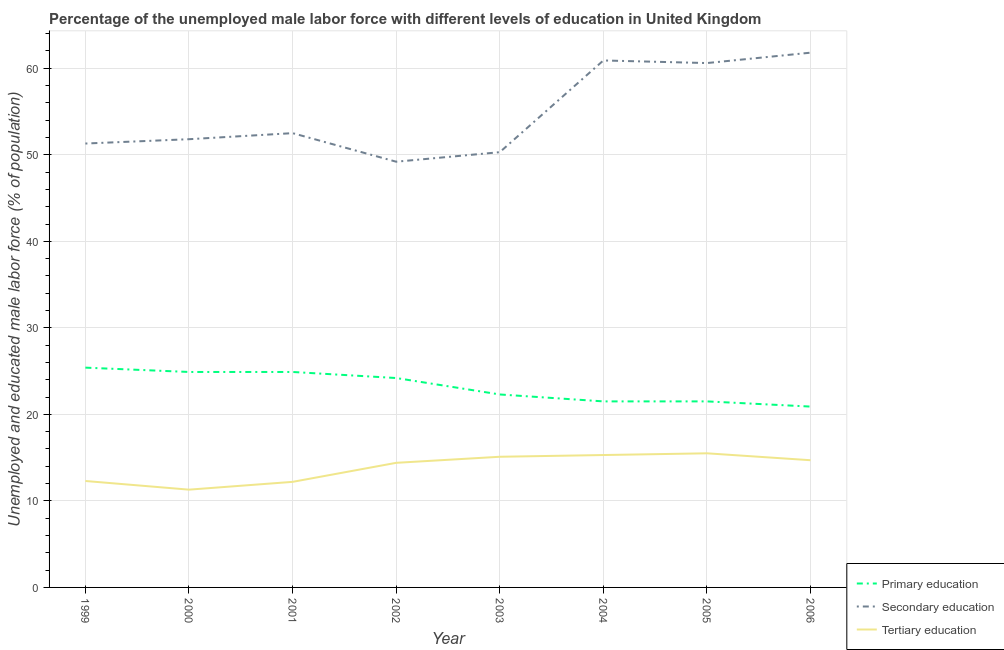Is the number of lines equal to the number of legend labels?
Your response must be concise. Yes. What is the percentage of male labor force who received primary education in 2002?
Your response must be concise. 24.2. Across all years, what is the minimum percentage of male labor force who received tertiary education?
Your response must be concise. 11.3. In which year was the percentage of male labor force who received primary education minimum?
Ensure brevity in your answer.  2006. What is the total percentage of male labor force who received primary education in the graph?
Your response must be concise. 185.6. What is the difference between the percentage of male labor force who received primary education in 2004 and that in 2006?
Offer a terse response. 0.6. What is the difference between the percentage of male labor force who received primary education in 2004 and the percentage of male labor force who received tertiary education in 2003?
Your answer should be compact. 6.4. What is the average percentage of male labor force who received secondary education per year?
Your answer should be compact. 54.8. In the year 2005, what is the difference between the percentage of male labor force who received primary education and percentage of male labor force who received tertiary education?
Provide a short and direct response. 6. In how many years, is the percentage of male labor force who received primary education greater than 24 %?
Your response must be concise. 4. What is the ratio of the percentage of male labor force who received secondary education in 2003 to that in 2005?
Offer a very short reply. 0.83. Is the percentage of male labor force who received secondary education in 1999 less than that in 2002?
Offer a very short reply. No. What is the difference between the highest and the second highest percentage of male labor force who received tertiary education?
Offer a terse response. 0.2. What is the difference between the highest and the lowest percentage of male labor force who received secondary education?
Your response must be concise. 12.6. Is the sum of the percentage of male labor force who received secondary education in 2003 and 2005 greater than the maximum percentage of male labor force who received tertiary education across all years?
Make the answer very short. Yes. How many lines are there?
Your answer should be compact. 3. How many years are there in the graph?
Make the answer very short. 8. What is the difference between two consecutive major ticks on the Y-axis?
Make the answer very short. 10. Are the values on the major ticks of Y-axis written in scientific E-notation?
Your response must be concise. No. Does the graph contain grids?
Your response must be concise. Yes. Where does the legend appear in the graph?
Provide a succinct answer. Bottom right. How are the legend labels stacked?
Give a very brief answer. Vertical. What is the title of the graph?
Provide a short and direct response. Percentage of the unemployed male labor force with different levels of education in United Kingdom. Does "Gaseous fuel" appear as one of the legend labels in the graph?
Make the answer very short. No. What is the label or title of the Y-axis?
Keep it short and to the point. Unemployed and educated male labor force (% of population). What is the Unemployed and educated male labor force (% of population) of Primary education in 1999?
Make the answer very short. 25.4. What is the Unemployed and educated male labor force (% of population) of Secondary education in 1999?
Offer a very short reply. 51.3. What is the Unemployed and educated male labor force (% of population) of Tertiary education in 1999?
Offer a terse response. 12.3. What is the Unemployed and educated male labor force (% of population) of Primary education in 2000?
Offer a terse response. 24.9. What is the Unemployed and educated male labor force (% of population) of Secondary education in 2000?
Give a very brief answer. 51.8. What is the Unemployed and educated male labor force (% of population) of Tertiary education in 2000?
Provide a succinct answer. 11.3. What is the Unemployed and educated male labor force (% of population) of Primary education in 2001?
Your response must be concise. 24.9. What is the Unemployed and educated male labor force (% of population) in Secondary education in 2001?
Provide a succinct answer. 52.5. What is the Unemployed and educated male labor force (% of population) of Tertiary education in 2001?
Your response must be concise. 12.2. What is the Unemployed and educated male labor force (% of population) of Primary education in 2002?
Make the answer very short. 24.2. What is the Unemployed and educated male labor force (% of population) of Secondary education in 2002?
Give a very brief answer. 49.2. What is the Unemployed and educated male labor force (% of population) of Tertiary education in 2002?
Keep it short and to the point. 14.4. What is the Unemployed and educated male labor force (% of population) of Primary education in 2003?
Your answer should be very brief. 22.3. What is the Unemployed and educated male labor force (% of population) of Secondary education in 2003?
Ensure brevity in your answer.  50.3. What is the Unemployed and educated male labor force (% of population) in Tertiary education in 2003?
Make the answer very short. 15.1. What is the Unemployed and educated male labor force (% of population) of Primary education in 2004?
Your answer should be very brief. 21.5. What is the Unemployed and educated male labor force (% of population) of Secondary education in 2004?
Provide a succinct answer. 60.9. What is the Unemployed and educated male labor force (% of population) in Tertiary education in 2004?
Offer a very short reply. 15.3. What is the Unemployed and educated male labor force (% of population) of Primary education in 2005?
Keep it short and to the point. 21.5. What is the Unemployed and educated male labor force (% of population) of Secondary education in 2005?
Provide a succinct answer. 60.6. What is the Unemployed and educated male labor force (% of population) of Tertiary education in 2005?
Your response must be concise. 15.5. What is the Unemployed and educated male labor force (% of population) of Primary education in 2006?
Make the answer very short. 20.9. What is the Unemployed and educated male labor force (% of population) of Secondary education in 2006?
Ensure brevity in your answer.  61.8. What is the Unemployed and educated male labor force (% of population) in Tertiary education in 2006?
Make the answer very short. 14.7. Across all years, what is the maximum Unemployed and educated male labor force (% of population) of Primary education?
Provide a short and direct response. 25.4. Across all years, what is the maximum Unemployed and educated male labor force (% of population) of Secondary education?
Your answer should be very brief. 61.8. Across all years, what is the maximum Unemployed and educated male labor force (% of population) of Tertiary education?
Your answer should be very brief. 15.5. Across all years, what is the minimum Unemployed and educated male labor force (% of population) in Primary education?
Ensure brevity in your answer.  20.9. Across all years, what is the minimum Unemployed and educated male labor force (% of population) of Secondary education?
Offer a very short reply. 49.2. Across all years, what is the minimum Unemployed and educated male labor force (% of population) in Tertiary education?
Your answer should be compact. 11.3. What is the total Unemployed and educated male labor force (% of population) of Primary education in the graph?
Ensure brevity in your answer.  185.6. What is the total Unemployed and educated male labor force (% of population) of Secondary education in the graph?
Offer a terse response. 438.4. What is the total Unemployed and educated male labor force (% of population) in Tertiary education in the graph?
Keep it short and to the point. 110.8. What is the difference between the Unemployed and educated male labor force (% of population) of Tertiary education in 1999 and that in 2000?
Provide a succinct answer. 1. What is the difference between the Unemployed and educated male labor force (% of population) in Primary education in 1999 and that in 2002?
Keep it short and to the point. 1.2. What is the difference between the Unemployed and educated male labor force (% of population) in Secondary education in 1999 and that in 2002?
Provide a short and direct response. 2.1. What is the difference between the Unemployed and educated male labor force (% of population) of Primary education in 1999 and that in 2003?
Ensure brevity in your answer.  3.1. What is the difference between the Unemployed and educated male labor force (% of population) of Tertiary education in 1999 and that in 2003?
Give a very brief answer. -2.8. What is the difference between the Unemployed and educated male labor force (% of population) in Secondary education in 1999 and that in 2004?
Make the answer very short. -9.6. What is the difference between the Unemployed and educated male labor force (% of population) of Tertiary education in 1999 and that in 2004?
Keep it short and to the point. -3. What is the difference between the Unemployed and educated male labor force (% of population) in Secondary education in 1999 and that in 2005?
Give a very brief answer. -9.3. What is the difference between the Unemployed and educated male labor force (% of population) in Secondary education in 1999 and that in 2006?
Your answer should be very brief. -10.5. What is the difference between the Unemployed and educated male labor force (% of population) of Tertiary education in 2000 and that in 2001?
Provide a short and direct response. -0.9. What is the difference between the Unemployed and educated male labor force (% of population) in Secondary education in 2000 and that in 2002?
Keep it short and to the point. 2.6. What is the difference between the Unemployed and educated male labor force (% of population) of Tertiary education in 2000 and that in 2002?
Your response must be concise. -3.1. What is the difference between the Unemployed and educated male labor force (% of population) in Primary education in 2000 and that in 2003?
Your response must be concise. 2.6. What is the difference between the Unemployed and educated male labor force (% of population) of Tertiary education in 2000 and that in 2004?
Keep it short and to the point. -4. What is the difference between the Unemployed and educated male labor force (% of population) of Primary education in 2000 and that in 2005?
Your answer should be very brief. 3.4. What is the difference between the Unemployed and educated male labor force (% of population) of Tertiary education in 2000 and that in 2005?
Make the answer very short. -4.2. What is the difference between the Unemployed and educated male labor force (% of population) in Primary education in 2000 and that in 2006?
Offer a terse response. 4. What is the difference between the Unemployed and educated male labor force (% of population) of Primary education in 2001 and that in 2002?
Give a very brief answer. 0.7. What is the difference between the Unemployed and educated male labor force (% of population) of Secondary education in 2001 and that in 2002?
Offer a very short reply. 3.3. What is the difference between the Unemployed and educated male labor force (% of population) of Secondary education in 2001 and that in 2003?
Your response must be concise. 2.2. What is the difference between the Unemployed and educated male labor force (% of population) in Tertiary education in 2001 and that in 2003?
Your answer should be compact. -2.9. What is the difference between the Unemployed and educated male labor force (% of population) in Primary education in 2001 and that in 2004?
Ensure brevity in your answer.  3.4. What is the difference between the Unemployed and educated male labor force (% of population) in Tertiary education in 2001 and that in 2004?
Offer a terse response. -3.1. What is the difference between the Unemployed and educated male labor force (% of population) in Secondary education in 2002 and that in 2003?
Offer a very short reply. -1.1. What is the difference between the Unemployed and educated male labor force (% of population) in Tertiary education in 2002 and that in 2003?
Keep it short and to the point. -0.7. What is the difference between the Unemployed and educated male labor force (% of population) in Primary education in 2002 and that in 2004?
Give a very brief answer. 2.7. What is the difference between the Unemployed and educated male labor force (% of population) of Tertiary education in 2002 and that in 2005?
Offer a very short reply. -1.1. What is the difference between the Unemployed and educated male labor force (% of population) in Secondary education in 2002 and that in 2006?
Ensure brevity in your answer.  -12.6. What is the difference between the Unemployed and educated male labor force (% of population) in Tertiary education in 2003 and that in 2004?
Provide a short and direct response. -0.2. What is the difference between the Unemployed and educated male labor force (% of population) in Secondary education in 2003 and that in 2005?
Keep it short and to the point. -10.3. What is the difference between the Unemployed and educated male labor force (% of population) in Tertiary education in 2003 and that in 2005?
Offer a terse response. -0.4. What is the difference between the Unemployed and educated male labor force (% of population) in Primary education in 2004 and that in 2005?
Your answer should be very brief. 0. What is the difference between the Unemployed and educated male labor force (% of population) in Secondary education in 2004 and that in 2006?
Offer a terse response. -0.9. What is the difference between the Unemployed and educated male labor force (% of population) in Primary education in 2005 and that in 2006?
Give a very brief answer. 0.6. What is the difference between the Unemployed and educated male labor force (% of population) in Tertiary education in 2005 and that in 2006?
Offer a very short reply. 0.8. What is the difference between the Unemployed and educated male labor force (% of population) in Primary education in 1999 and the Unemployed and educated male labor force (% of population) in Secondary education in 2000?
Offer a terse response. -26.4. What is the difference between the Unemployed and educated male labor force (% of population) in Primary education in 1999 and the Unemployed and educated male labor force (% of population) in Tertiary education in 2000?
Your response must be concise. 14.1. What is the difference between the Unemployed and educated male labor force (% of population) of Primary education in 1999 and the Unemployed and educated male labor force (% of population) of Secondary education in 2001?
Provide a succinct answer. -27.1. What is the difference between the Unemployed and educated male labor force (% of population) in Primary education in 1999 and the Unemployed and educated male labor force (% of population) in Tertiary education in 2001?
Ensure brevity in your answer.  13.2. What is the difference between the Unemployed and educated male labor force (% of population) in Secondary education in 1999 and the Unemployed and educated male labor force (% of population) in Tertiary education in 2001?
Offer a terse response. 39.1. What is the difference between the Unemployed and educated male labor force (% of population) of Primary education in 1999 and the Unemployed and educated male labor force (% of population) of Secondary education in 2002?
Your answer should be compact. -23.8. What is the difference between the Unemployed and educated male labor force (% of population) of Primary education in 1999 and the Unemployed and educated male labor force (% of population) of Tertiary education in 2002?
Your answer should be compact. 11. What is the difference between the Unemployed and educated male labor force (% of population) in Secondary education in 1999 and the Unemployed and educated male labor force (% of population) in Tertiary education in 2002?
Make the answer very short. 36.9. What is the difference between the Unemployed and educated male labor force (% of population) of Primary education in 1999 and the Unemployed and educated male labor force (% of population) of Secondary education in 2003?
Make the answer very short. -24.9. What is the difference between the Unemployed and educated male labor force (% of population) of Secondary education in 1999 and the Unemployed and educated male labor force (% of population) of Tertiary education in 2003?
Ensure brevity in your answer.  36.2. What is the difference between the Unemployed and educated male labor force (% of population) in Primary education in 1999 and the Unemployed and educated male labor force (% of population) in Secondary education in 2004?
Your answer should be compact. -35.5. What is the difference between the Unemployed and educated male labor force (% of population) in Primary education in 1999 and the Unemployed and educated male labor force (% of population) in Tertiary education in 2004?
Make the answer very short. 10.1. What is the difference between the Unemployed and educated male labor force (% of population) in Primary education in 1999 and the Unemployed and educated male labor force (% of population) in Secondary education in 2005?
Keep it short and to the point. -35.2. What is the difference between the Unemployed and educated male labor force (% of population) of Primary education in 1999 and the Unemployed and educated male labor force (% of population) of Tertiary education in 2005?
Make the answer very short. 9.9. What is the difference between the Unemployed and educated male labor force (% of population) of Secondary education in 1999 and the Unemployed and educated male labor force (% of population) of Tertiary education in 2005?
Ensure brevity in your answer.  35.8. What is the difference between the Unemployed and educated male labor force (% of population) of Primary education in 1999 and the Unemployed and educated male labor force (% of population) of Secondary education in 2006?
Ensure brevity in your answer.  -36.4. What is the difference between the Unemployed and educated male labor force (% of population) in Secondary education in 1999 and the Unemployed and educated male labor force (% of population) in Tertiary education in 2006?
Provide a succinct answer. 36.6. What is the difference between the Unemployed and educated male labor force (% of population) of Primary education in 2000 and the Unemployed and educated male labor force (% of population) of Secondary education in 2001?
Your answer should be compact. -27.6. What is the difference between the Unemployed and educated male labor force (% of population) of Primary education in 2000 and the Unemployed and educated male labor force (% of population) of Tertiary education in 2001?
Give a very brief answer. 12.7. What is the difference between the Unemployed and educated male labor force (% of population) of Secondary education in 2000 and the Unemployed and educated male labor force (% of population) of Tertiary education in 2001?
Make the answer very short. 39.6. What is the difference between the Unemployed and educated male labor force (% of population) of Primary education in 2000 and the Unemployed and educated male labor force (% of population) of Secondary education in 2002?
Your answer should be compact. -24.3. What is the difference between the Unemployed and educated male labor force (% of population) of Secondary education in 2000 and the Unemployed and educated male labor force (% of population) of Tertiary education in 2002?
Your answer should be compact. 37.4. What is the difference between the Unemployed and educated male labor force (% of population) in Primary education in 2000 and the Unemployed and educated male labor force (% of population) in Secondary education in 2003?
Your response must be concise. -25.4. What is the difference between the Unemployed and educated male labor force (% of population) of Secondary education in 2000 and the Unemployed and educated male labor force (% of population) of Tertiary education in 2003?
Provide a succinct answer. 36.7. What is the difference between the Unemployed and educated male labor force (% of population) of Primary education in 2000 and the Unemployed and educated male labor force (% of population) of Secondary education in 2004?
Your answer should be compact. -36. What is the difference between the Unemployed and educated male labor force (% of population) of Secondary education in 2000 and the Unemployed and educated male labor force (% of population) of Tertiary education in 2004?
Give a very brief answer. 36.5. What is the difference between the Unemployed and educated male labor force (% of population) of Primary education in 2000 and the Unemployed and educated male labor force (% of population) of Secondary education in 2005?
Your answer should be compact. -35.7. What is the difference between the Unemployed and educated male labor force (% of population) of Primary education in 2000 and the Unemployed and educated male labor force (% of population) of Tertiary education in 2005?
Offer a very short reply. 9.4. What is the difference between the Unemployed and educated male labor force (% of population) of Secondary education in 2000 and the Unemployed and educated male labor force (% of population) of Tertiary education in 2005?
Your response must be concise. 36.3. What is the difference between the Unemployed and educated male labor force (% of population) in Primary education in 2000 and the Unemployed and educated male labor force (% of population) in Secondary education in 2006?
Make the answer very short. -36.9. What is the difference between the Unemployed and educated male labor force (% of population) in Secondary education in 2000 and the Unemployed and educated male labor force (% of population) in Tertiary education in 2006?
Offer a very short reply. 37.1. What is the difference between the Unemployed and educated male labor force (% of population) in Primary education in 2001 and the Unemployed and educated male labor force (% of population) in Secondary education in 2002?
Make the answer very short. -24.3. What is the difference between the Unemployed and educated male labor force (% of population) in Primary education in 2001 and the Unemployed and educated male labor force (% of population) in Tertiary education in 2002?
Offer a terse response. 10.5. What is the difference between the Unemployed and educated male labor force (% of population) of Secondary education in 2001 and the Unemployed and educated male labor force (% of population) of Tertiary education in 2002?
Your answer should be compact. 38.1. What is the difference between the Unemployed and educated male labor force (% of population) of Primary education in 2001 and the Unemployed and educated male labor force (% of population) of Secondary education in 2003?
Your answer should be compact. -25.4. What is the difference between the Unemployed and educated male labor force (% of population) in Primary education in 2001 and the Unemployed and educated male labor force (% of population) in Tertiary education in 2003?
Make the answer very short. 9.8. What is the difference between the Unemployed and educated male labor force (% of population) of Secondary education in 2001 and the Unemployed and educated male labor force (% of population) of Tertiary education in 2003?
Provide a succinct answer. 37.4. What is the difference between the Unemployed and educated male labor force (% of population) of Primary education in 2001 and the Unemployed and educated male labor force (% of population) of Secondary education in 2004?
Your answer should be compact. -36. What is the difference between the Unemployed and educated male labor force (% of population) of Secondary education in 2001 and the Unemployed and educated male labor force (% of population) of Tertiary education in 2004?
Offer a terse response. 37.2. What is the difference between the Unemployed and educated male labor force (% of population) in Primary education in 2001 and the Unemployed and educated male labor force (% of population) in Secondary education in 2005?
Make the answer very short. -35.7. What is the difference between the Unemployed and educated male labor force (% of population) in Primary education in 2001 and the Unemployed and educated male labor force (% of population) in Tertiary education in 2005?
Offer a very short reply. 9.4. What is the difference between the Unemployed and educated male labor force (% of population) of Secondary education in 2001 and the Unemployed and educated male labor force (% of population) of Tertiary education in 2005?
Keep it short and to the point. 37. What is the difference between the Unemployed and educated male labor force (% of population) of Primary education in 2001 and the Unemployed and educated male labor force (% of population) of Secondary education in 2006?
Provide a short and direct response. -36.9. What is the difference between the Unemployed and educated male labor force (% of population) in Secondary education in 2001 and the Unemployed and educated male labor force (% of population) in Tertiary education in 2006?
Offer a terse response. 37.8. What is the difference between the Unemployed and educated male labor force (% of population) of Primary education in 2002 and the Unemployed and educated male labor force (% of population) of Secondary education in 2003?
Offer a terse response. -26.1. What is the difference between the Unemployed and educated male labor force (% of population) of Secondary education in 2002 and the Unemployed and educated male labor force (% of population) of Tertiary education in 2003?
Your response must be concise. 34.1. What is the difference between the Unemployed and educated male labor force (% of population) of Primary education in 2002 and the Unemployed and educated male labor force (% of population) of Secondary education in 2004?
Your response must be concise. -36.7. What is the difference between the Unemployed and educated male labor force (% of population) of Secondary education in 2002 and the Unemployed and educated male labor force (% of population) of Tertiary education in 2004?
Offer a terse response. 33.9. What is the difference between the Unemployed and educated male labor force (% of population) of Primary education in 2002 and the Unemployed and educated male labor force (% of population) of Secondary education in 2005?
Your response must be concise. -36.4. What is the difference between the Unemployed and educated male labor force (% of population) in Secondary education in 2002 and the Unemployed and educated male labor force (% of population) in Tertiary education in 2005?
Offer a very short reply. 33.7. What is the difference between the Unemployed and educated male labor force (% of population) of Primary education in 2002 and the Unemployed and educated male labor force (% of population) of Secondary education in 2006?
Offer a very short reply. -37.6. What is the difference between the Unemployed and educated male labor force (% of population) of Primary education in 2002 and the Unemployed and educated male labor force (% of population) of Tertiary education in 2006?
Your answer should be very brief. 9.5. What is the difference between the Unemployed and educated male labor force (% of population) of Secondary education in 2002 and the Unemployed and educated male labor force (% of population) of Tertiary education in 2006?
Give a very brief answer. 34.5. What is the difference between the Unemployed and educated male labor force (% of population) of Primary education in 2003 and the Unemployed and educated male labor force (% of population) of Secondary education in 2004?
Give a very brief answer. -38.6. What is the difference between the Unemployed and educated male labor force (% of population) in Primary education in 2003 and the Unemployed and educated male labor force (% of population) in Tertiary education in 2004?
Ensure brevity in your answer.  7. What is the difference between the Unemployed and educated male labor force (% of population) in Secondary education in 2003 and the Unemployed and educated male labor force (% of population) in Tertiary education in 2004?
Keep it short and to the point. 35. What is the difference between the Unemployed and educated male labor force (% of population) of Primary education in 2003 and the Unemployed and educated male labor force (% of population) of Secondary education in 2005?
Your response must be concise. -38.3. What is the difference between the Unemployed and educated male labor force (% of population) of Secondary education in 2003 and the Unemployed and educated male labor force (% of population) of Tertiary education in 2005?
Provide a succinct answer. 34.8. What is the difference between the Unemployed and educated male labor force (% of population) in Primary education in 2003 and the Unemployed and educated male labor force (% of population) in Secondary education in 2006?
Your response must be concise. -39.5. What is the difference between the Unemployed and educated male labor force (% of population) in Primary education in 2003 and the Unemployed and educated male labor force (% of population) in Tertiary education in 2006?
Ensure brevity in your answer.  7.6. What is the difference between the Unemployed and educated male labor force (% of population) in Secondary education in 2003 and the Unemployed and educated male labor force (% of population) in Tertiary education in 2006?
Provide a succinct answer. 35.6. What is the difference between the Unemployed and educated male labor force (% of population) of Primary education in 2004 and the Unemployed and educated male labor force (% of population) of Secondary education in 2005?
Your answer should be very brief. -39.1. What is the difference between the Unemployed and educated male labor force (% of population) of Secondary education in 2004 and the Unemployed and educated male labor force (% of population) of Tertiary education in 2005?
Your answer should be very brief. 45.4. What is the difference between the Unemployed and educated male labor force (% of population) of Primary education in 2004 and the Unemployed and educated male labor force (% of population) of Secondary education in 2006?
Make the answer very short. -40.3. What is the difference between the Unemployed and educated male labor force (% of population) in Primary education in 2004 and the Unemployed and educated male labor force (% of population) in Tertiary education in 2006?
Make the answer very short. 6.8. What is the difference between the Unemployed and educated male labor force (% of population) of Secondary education in 2004 and the Unemployed and educated male labor force (% of population) of Tertiary education in 2006?
Your response must be concise. 46.2. What is the difference between the Unemployed and educated male labor force (% of population) of Primary education in 2005 and the Unemployed and educated male labor force (% of population) of Secondary education in 2006?
Offer a very short reply. -40.3. What is the difference between the Unemployed and educated male labor force (% of population) in Primary education in 2005 and the Unemployed and educated male labor force (% of population) in Tertiary education in 2006?
Provide a succinct answer. 6.8. What is the difference between the Unemployed and educated male labor force (% of population) of Secondary education in 2005 and the Unemployed and educated male labor force (% of population) of Tertiary education in 2006?
Give a very brief answer. 45.9. What is the average Unemployed and educated male labor force (% of population) of Primary education per year?
Your response must be concise. 23.2. What is the average Unemployed and educated male labor force (% of population) of Secondary education per year?
Offer a terse response. 54.8. What is the average Unemployed and educated male labor force (% of population) of Tertiary education per year?
Provide a short and direct response. 13.85. In the year 1999, what is the difference between the Unemployed and educated male labor force (% of population) of Primary education and Unemployed and educated male labor force (% of population) of Secondary education?
Provide a succinct answer. -25.9. In the year 2000, what is the difference between the Unemployed and educated male labor force (% of population) in Primary education and Unemployed and educated male labor force (% of population) in Secondary education?
Your answer should be compact. -26.9. In the year 2000, what is the difference between the Unemployed and educated male labor force (% of population) of Secondary education and Unemployed and educated male labor force (% of population) of Tertiary education?
Provide a short and direct response. 40.5. In the year 2001, what is the difference between the Unemployed and educated male labor force (% of population) in Primary education and Unemployed and educated male labor force (% of population) in Secondary education?
Make the answer very short. -27.6. In the year 2001, what is the difference between the Unemployed and educated male labor force (% of population) of Secondary education and Unemployed and educated male labor force (% of population) of Tertiary education?
Provide a succinct answer. 40.3. In the year 2002, what is the difference between the Unemployed and educated male labor force (% of population) of Primary education and Unemployed and educated male labor force (% of population) of Secondary education?
Keep it short and to the point. -25. In the year 2002, what is the difference between the Unemployed and educated male labor force (% of population) in Secondary education and Unemployed and educated male labor force (% of population) in Tertiary education?
Keep it short and to the point. 34.8. In the year 2003, what is the difference between the Unemployed and educated male labor force (% of population) in Secondary education and Unemployed and educated male labor force (% of population) in Tertiary education?
Give a very brief answer. 35.2. In the year 2004, what is the difference between the Unemployed and educated male labor force (% of population) in Primary education and Unemployed and educated male labor force (% of population) in Secondary education?
Offer a terse response. -39.4. In the year 2004, what is the difference between the Unemployed and educated male labor force (% of population) of Secondary education and Unemployed and educated male labor force (% of population) of Tertiary education?
Provide a succinct answer. 45.6. In the year 2005, what is the difference between the Unemployed and educated male labor force (% of population) of Primary education and Unemployed and educated male labor force (% of population) of Secondary education?
Provide a succinct answer. -39.1. In the year 2005, what is the difference between the Unemployed and educated male labor force (% of population) of Primary education and Unemployed and educated male labor force (% of population) of Tertiary education?
Ensure brevity in your answer.  6. In the year 2005, what is the difference between the Unemployed and educated male labor force (% of population) of Secondary education and Unemployed and educated male labor force (% of population) of Tertiary education?
Offer a terse response. 45.1. In the year 2006, what is the difference between the Unemployed and educated male labor force (% of population) in Primary education and Unemployed and educated male labor force (% of population) in Secondary education?
Offer a terse response. -40.9. In the year 2006, what is the difference between the Unemployed and educated male labor force (% of population) of Primary education and Unemployed and educated male labor force (% of population) of Tertiary education?
Offer a very short reply. 6.2. In the year 2006, what is the difference between the Unemployed and educated male labor force (% of population) in Secondary education and Unemployed and educated male labor force (% of population) in Tertiary education?
Ensure brevity in your answer.  47.1. What is the ratio of the Unemployed and educated male labor force (% of population) of Primary education in 1999 to that in 2000?
Provide a succinct answer. 1.02. What is the ratio of the Unemployed and educated male labor force (% of population) in Secondary education in 1999 to that in 2000?
Your response must be concise. 0.99. What is the ratio of the Unemployed and educated male labor force (% of population) in Tertiary education in 1999 to that in 2000?
Provide a short and direct response. 1.09. What is the ratio of the Unemployed and educated male labor force (% of population) of Primary education in 1999 to that in 2001?
Make the answer very short. 1.02. What is the ratio of the Unemployed and educated male labor force (% of population) in Secondary education in 1999 to that in 2001?
Make the answer very short. 0.98. What is the ratio of the Unemployed and educated male labor force (% of population) of Tertiary education in 1999 to that in 2001?
Offer a very short reply. 1.01. What is the ratio of the Unemployed and educated male labor force (% of population) in Primary education in 1999 to that in 2002?
Your response must be concise. 1.05. What is the ratio of the Unemployed and educated male labor force (% of population) of Secondary education in 1999 to that in 2002?
Offer a terse response. 1.04. What is the ratio of the Unemployed and educated male labor force (% of population) in Tertiary education in 1999 to that in 2002?
Offer a very short reply. 0.85. What is the ratio of the Unemployed and educated male labor force (% of population) of Primary education in 1999 to that in 2003?
Your answer should be compact. 1.14. What is the ratio of the Unemployed and educated male labor force (% of population) in Secondary education in 1999 to that in 2003?
Offer a very short reply. 1.02. What is the ratio of the Unemployed and educated male labor force (% of population) in Tertiary education in 1999 to that in 2003?
Give a very brief answer. 0.81. What is the ratio of the Unemployed and educated male labor force (% of population) of Primary education in 1999 to that in 2004?
Keep it short and to the point. 1.18. What is the ratio of the Unemployed and educated male labor force (% of population) of Secondary education in 1999 to that in 2004?
Give a very brief answer. 0.84. What is the ratio of the Unemployed and educated male labor force (% of population) in Tertiary education in 1999 to that in 2004?
Your answer should be very brief. 0.8. What is the ratio of the Unemployed and educated male labor force (% of population) of Primary education in 1999 to that in 2005?
Your answer should be compact. 1.18. What is the ratio of the Unemployed and educated male labor force (% of population) in Secondary education in 1999 to that in 2005?
Your answer should be compact. 0.85. What is the ratio of the Unemployed and educated male labor force (% of population) in Tertiary education in 1999 to that in 2005?
Your response must be concise. 0.79. What is the ratio of the Unemployed and educated male labor force (% of population) of Primary education in 1999 to that in 2006?
Ensure brevity in your answer.  1.22. What is the ratio of the Unemployed and educated male labor force (% of population) in Secondary education in 1999 to that in 2006?
Provide a succinct answer. 0.83. What is the ratio of the Unemployed and educated male labor force (% of population) of Tertiary education in 1999 to that in 2006?
Your answer should be compact. 0.84. What is the ratio of the Unemployed and educated male labor force (% of population) in Primary education in 2000 to that in 2001?
Ensure brevity in your answer.  1. What is the ratio of the Unemployed and educated male labor force (% of population) in Secondary education in 2000 to that in 2001?
Provide a succinct answer. 0.99. What is the ratio of the Unemployed and educated male labor force (% of population) in Tertiary education in 2000 to that in 2001?
Offer a very short reply. 0.93. What is the ratio of the Unemployed and educated male labor force (% of population) in Primary education in 2000 to that in 2002?
Give a very brief answer. 1.03. What is the ratio of the Unemployed and educated male labor force (% of population) of Secondary education in 2000 to that in 2002?
Your response must be concise. 1.05. What is the ratio of the Unemployed and educated male labor force (% of population) of Tertiary education in 2000 to that in 2002?
Give a very brief answer. 0.78. What is the ratio of the Unemployed and educated male labor force (% of population) in Primary education in 2000 to that in 2003?
Keep it short and to the point. 1.12. What is the ratio of the Unemployed and educated male labor force (% of population) of Secondary education in 2000 to that in 2003?
Make the answer very short. 1.03. What is the ratio of the Unemployed and educated male labor force (% of population) in Tertiary education in 2000 to that in 2003?
Keep it short and to the point. 0.75. What is the ratio of the Unemployed and educated male labor force (% of population) of Primary education in 2000 to that in 2004?
Keep it short and to the point. 1.16. What is the ratio of the Unemployed and educated male labor force (% of population) in Secondary education in 2000 to that in 2004?
Give a very brief answer. 0.85. What is the ratio of the Unemployed and educated male labor force (% of population) in Tertiary education in 2000 to that in 2004?
Give a very brief answer. 0.74. What is the ratio of the Unemployed and educated male labor force (% of population) of Primary education in 2000 to that in 2005?
Keep it short and to the point. 1.16. What is the ratio of the Unemployed and educated male labor force (% of population) in Secondary education in 2000 to that in 2005?
Ensure brevity in your answer.  0.85. What is the ratio of the Unemployed and educated male labor force (% of population) in Tertiary education in 2000 to that in 2005?
Provide a succinct answer. 0.73. What is the ratio of the Unemployed and educated male labor force (% of population) in Primary education in 2000 to that in 2006?
Your answer should be very brief. 1.19. What is the ratio of the Unemployed and educated male labor force (% of population) in Secondary education in 2000 to that in 2006?
Your answer should be compact. 0.84. What is the ratio of the Unemployed and educated male labor force (% of population) of Tertiary education in 2000 to that in 2006?
Ensure brevity in your answer.  0.77. What is the ratio of the Unemployed and educated male labor force (% of population) in Primary education in 2001 to that in 2002?
Offer a very short reply. 1.03. What is the ratio of the Unemployed and educated male labor force (% of population) in Secondary education in 2001 to that in 2002?
Your response must be concise. 1.07. What is the ratio of the Unemployed and educated male labor force (% of population) in Tertiary education in 2001 to that in 2002?
Provide a short and direct response. 0.85. What is the ratio of the Unemployed and educated male labor force (% of population) in Primary education in 2001 to that in 2003?
Make the answer very short. 1.12. What is the ratio of the Unemployed and educated male labor force (% of population) in Secondary education in 2001 to that in 2003?
Give a very brief answer. 1.04. What is the ratio of the Unemployed and educated male labor force (% of population) in Tertiary education in 2001 to that in 2003?
Provide a succinct answer. 0.81. What is the ratio of the Unemployed and educated male labor force (% of population) of Primary education in 2001 to that in 2004?
Ensure brevity in your answer.  1.16. What is the ratio of the Unemployed and educated male labor force (% of population) in Secondary education in 2001 to that in 2004?
Your response must be concise. 0.86. What is the ratio of the Unemployed and educated male labor force (% of population) of Tertiary education in 2001 to that in 2004?
Your answer should be compact. 0.8. What is the ratio of the Unemployed and educated male labor force (% of population) in Primary education in 2001 to that in 2005?
Provide a short and direct response. 1.16. What is the ratio of the Unemployed and educated male labor force (% of population) of Secondary education in 2001 to that in 2005?
Provide a succinct answer. 0.87. What is the ratio of the Unemployed and educated male labor force (% of population) of Tertiary education in 2001 to that in 2005?
Provide a succinct answer. 0.79. What is the ratio of the Unemployed and educated male labor force (% of population) of Primary education in 2001 to that in 2006?
Offer a very short reply. 1.19. What is the ratio of the Unemployed and educated male labor force (% of population) of Secondary education in 2001 to that in 2006?
Provide a succinct answer. 0.85. What is the ratio of the Unemployed and educated male labor force (% of population) of Tertiary education in 2001 to that in 2006?
Make the answer very short. 0.83. What is the ratio of the Unemployed and educated male labor force (% of population) of Primary education in 2002 to that in 2003?
Provide a succinct answer. 1.09. What is the ratio of the Unemployed and educated male labor force (% of population) in Secondary education in 2002 to that in 2003?
Provide a succinct answer. 0.98. What is the ratio of the Unemployed and educated male labor force (% of population) in Tertiary education in 2002 to that in 2003?
Ensure brevity in your answer.  0.95. What is the ratio of the Unemployed and educated male labor force (% of population) of Primary education in 2002 to that in 2004?
Make the answer very short. 1.13. What is the ratio of the Unemployed and educated male labor force (% of population) of Secondary education in 2002 to that in 2004?
Keep it short and to the point. 0.81. What is the ratio of the Unemployed and educated male labor force (% of population) in Primary education in 2002 to that in 2005?
Ensure brevity in your answer.  1.13. What is the ratio of the Unemployed and educated male labor force (% of population) in Secondary education in 2002 to that in 2005?
Ensure brevity in your answer.  0.81. What is the ratio of the Unemployed and educated male labor force (% of population) of Tertiary education in 2002 to that in 2005?
Make the answer very short. 0.93. What is the ratio of the Unemployed and educated male labor force (% of population) in Primary education in 2002 to that in 2006?
Your response must be concise. 1.16. What is the ratio of the Unemployed and educated male labor force (% of population) of Secondary education in 2002 to that in 2006?
Provide a short and direct response. 0.8. What is the ratio of the Unemployed and educated male labor force (% of population) of Tertiary education in 2002 to that in 2006?
Your answer should be compact. 0.98. What is the ratio of the Unemployed and educated male labor force (% of population) of Primary education in 2003 to that in 2004?
Provide a succinct answer. 1.04. What is the ratio of the Unemployed and educated male labor force (% of population) in Secondary education in 2003 to that in 2004?
Your response must be concise. 0.83. What is the ratio of the Unemployed and educated male labor force (% of population) in Tertiary education in 2003 to that in 2004?
Offer a very short reply. 0.99. What is the ratio of the Unemployed and educated male labor force (% of population) in Primary education in 2003 to that in 2005?
Offer a very short reply. 1.04. What is the ratio of the Unemployed and educated male labor force (% of population) in Secondary education in 2003 to that in 2005?
Provide a short and direct response. 0.83. What is the ratio of the Unemployed and educated male labor force (% of population) in Tertiary education in 2003 to that in 2005?
Ensure brevity in your answer.  0.97. What is the ratio of the Unemployed and educated male labor force (% of population) in Primary education in 2003 to that in 2006?
Keep it short and to the point. 1.07. What is the ratio of the Unemployed and educated male labor force (% of population) in Secondary education in 2003 to that in 2006?
Your answer should be compact. 0.81. What is the ratio of the Unemployed and educated male labor force (% of population) of Tertiary education in 2003 to that in 2006?
Give a very brief answer. 1.03. What is the ratio of the Unemployed and educated male labor force (% of population) of Secondary education in 2004 to that in 2005?
Your response must be concise. 1. What is the ratio of the Unemployed and educated male labor force (% of population) in Tertiary education in 2004 to that in 2005?
Provide a short and direct response. 0.99. What is the ratio of the Unemployed and educated male labor force (% of population) of Primary education in 2004 to that in 2006?
Make the answer very short. 1.03. What is the ratio of the Unemployed and educated male labor force (% of population) of Secondary education in 2004 to that in 2006?
Provide a succinct answer. 0.99. What is the ratio of the Unemployed and educated male labor force (% of population) of Tertiary education in 2004 to that in 2006?
Provide a short and direct response. 1.04. What is the ratio of the Unemployed and educated male labor force (% of population) in Primary education in 2005 to that in 2006?
Keep it short and to the point. 1.03. What is the ratio of the Unemployed and educated male labor force (% of population) in Secondary education in 2005 to that in 2006?
Keep it short and to the point. 0.98. What is the ratio of the Unemployed and educated male labor force (% of population) of Tertiary education in 2005 to that in 2006?
Provide a succinct answer. 1.05. What is the difference between the highest and the second highest Unemployed and educated male labor force (% of population) in Secondary education?
Give a very brief answer. 0.9. What is the difference between the highest and the second highest Unemployed and educated male labor force (% of population) of Tertiary education?
Ensure brevity in your answer.  0.2. What is the difference between the highest and the lowest Unemployed and educated male labor force (% of population) of Primary education?
Give a very brief answer. 4.5. What is the difference between the highest and the lowest Unemployed and educated male labor force (% of population) of Secondary education?
Offer a very short reply. 12.6. What is the difference between the highest and the lowest Unemployed and educated male labor force (% of population) in Tertiary education?
Make the answer very short. 4.2. 